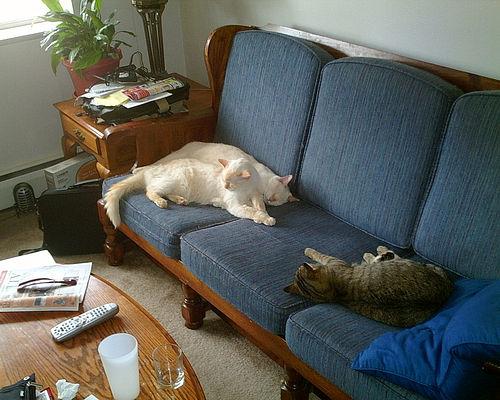How many cats are sleeping on the left?
Write a very short answer. 1. Which two cats look like siblings?
Answer briefly. White ones. How many cups sit on the coffee table?
Keep it brief. 2. 